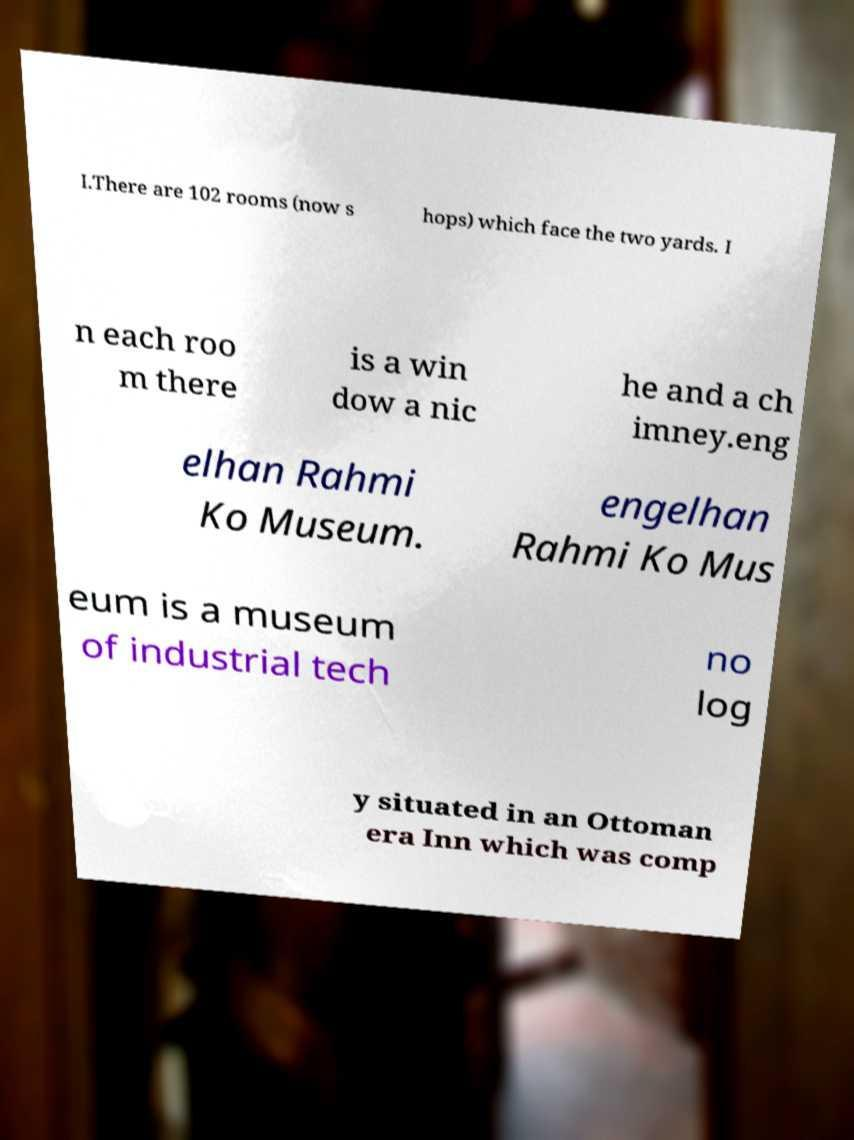I need the written content from this picture converted into text. Can you do that? I.There are 102 rooms (now s hops) which face the two yards. I n each roo m there is a win dow a nic he and a ch imney.eng elhan Rahmi Ko Museum. engelhan Rahmi Ko Mus eum is a museum of industrial tech no log y situated in an Ottoman era Inn which was comp 